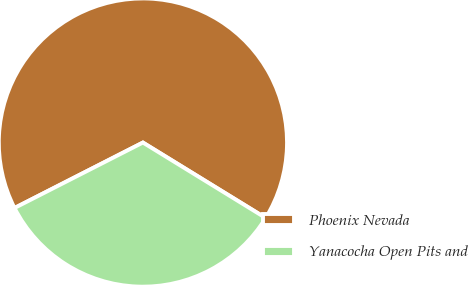Convert chart. <chart><loc_0><loc_0><loc_500><loc_500><pie_chart><fcel>Phoenix Nevada<fcel>Yanacocha Open Pits and<nl><fcel>66.27%<fcel>33.73%<nl></chart> 